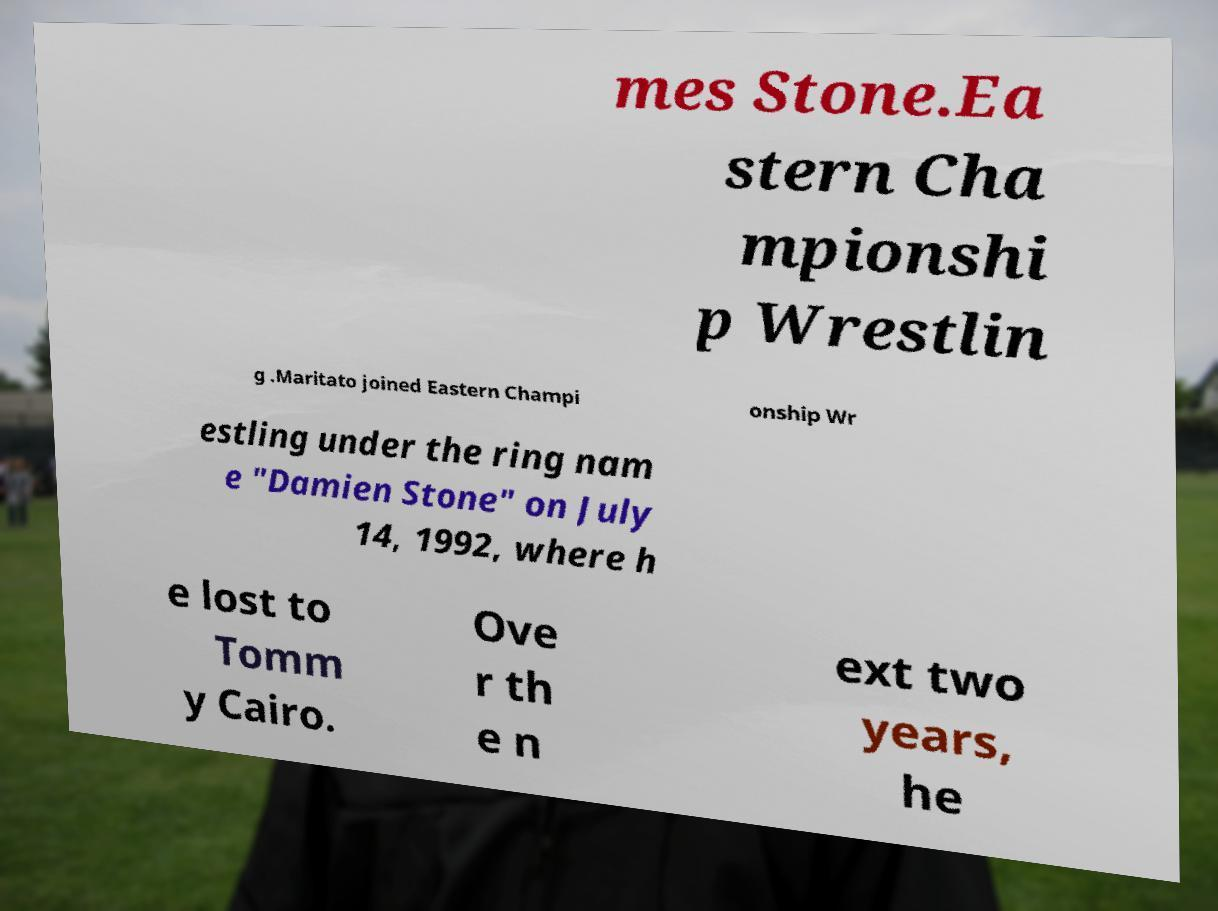Could you assist in decoding the text presented in this image and type it out clearly? mes Stone.Ea stern Cha mpionshi p Wrestlin g .Maritato joined Eastern Champi onship Wr estling under the ring nam e "Damien Stone" on July 14, 1992, where h e lost to Tomm y Cairo. Ove r th e n ext two years, he 